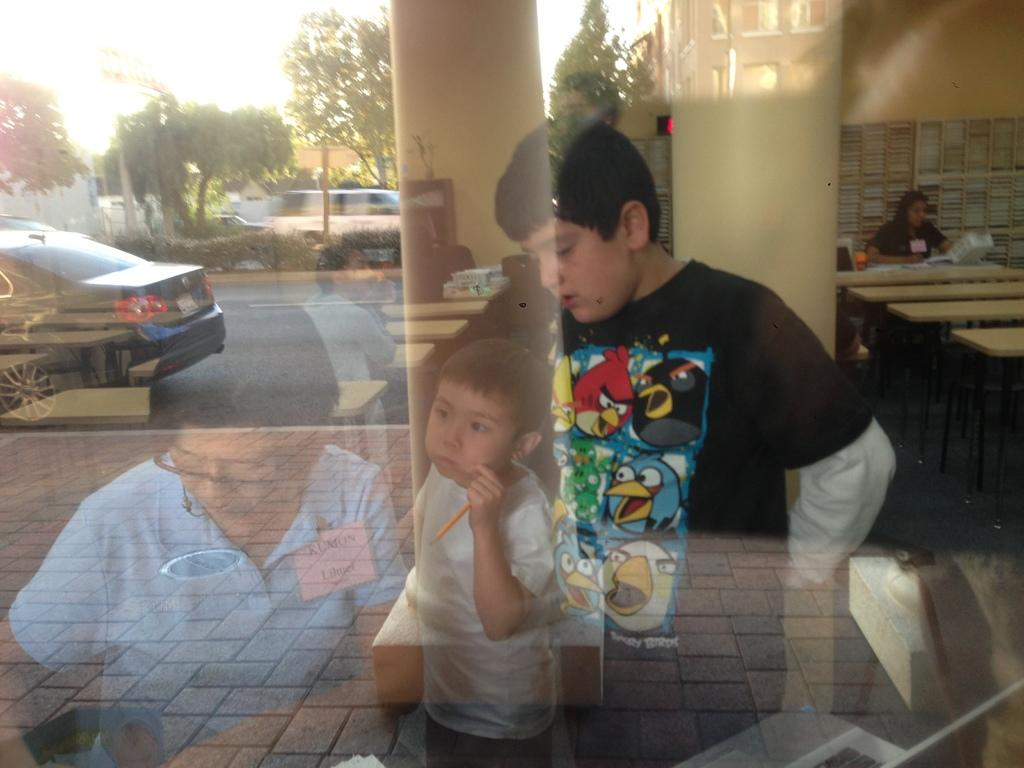Who or what is present in the image? There are people in the image. What can be observed about the people in the image? There is a reflection of the people on the glass. What type of structures can be seen in the image? There are buildings visible in the image. What natural elements are present in the image? There are trees in the image. What mode of transportation can be seen in the image? There is a car on the road in the image. Can you tell me how many giraffes are walking on the road in the image? There are no giraffes present in the image; it features a car on the road. What type of magic is being performed by the people in the image? There is no indication of magic or any magical elements in the image. 